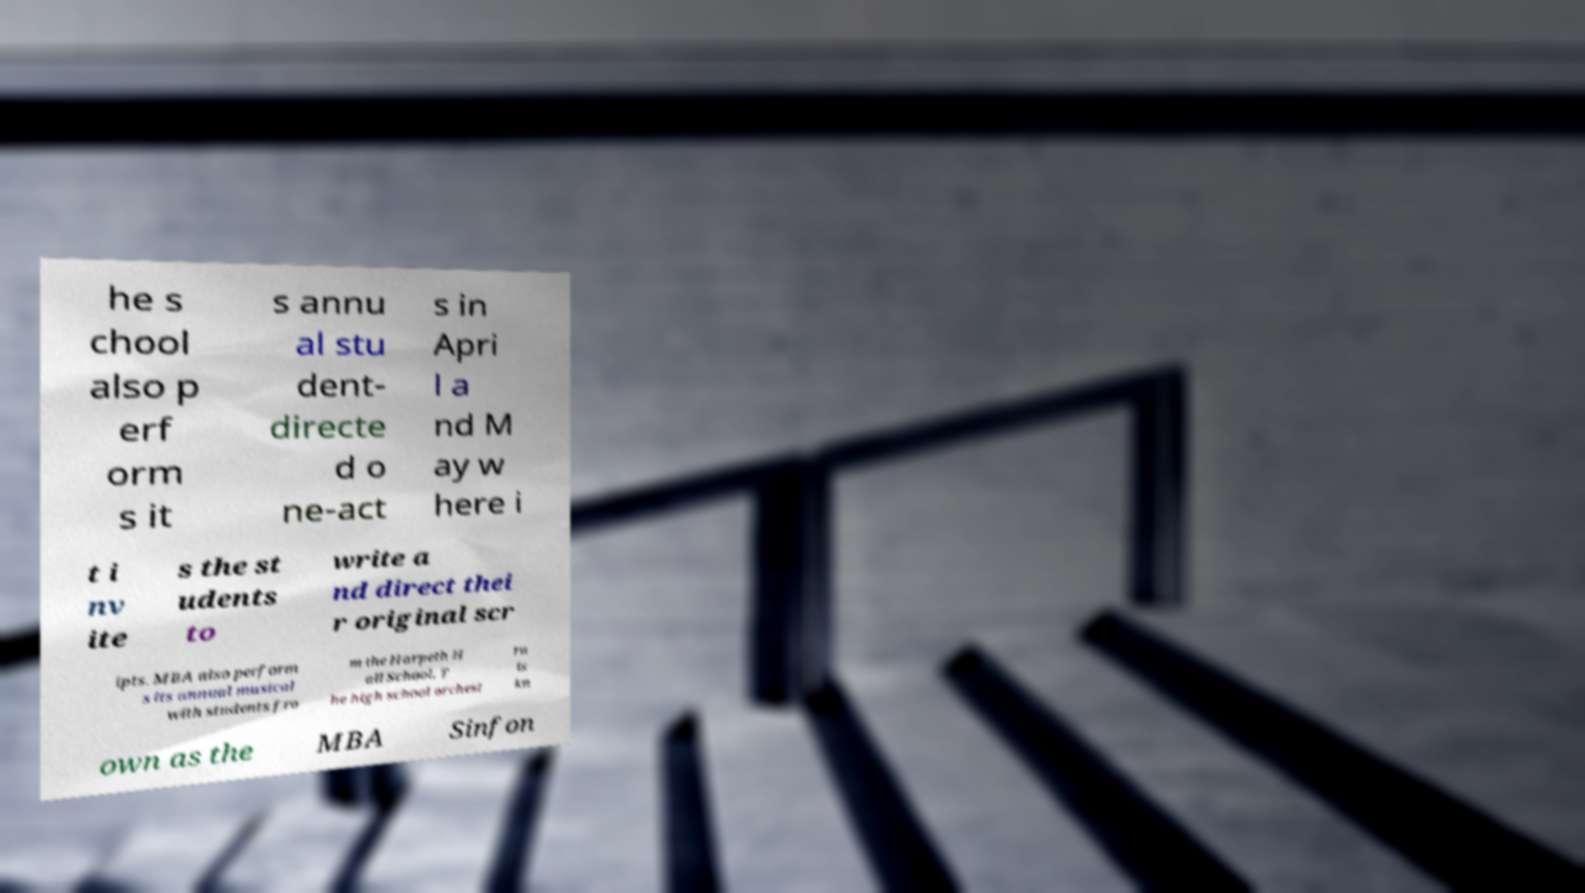Please identify and transcribe the text found in this image. he s chool also p erf orm s it s annu al stu dent- directe d o ne-act s in Apri l a nd M ay w here i t i nv ite s the st udents to write a nd direct thei r original scr ipts. MBA also perform s its annual musical with students fro m the Harpeth H all School. T he high school orchest ra is kn own as the MBA Sinfon 